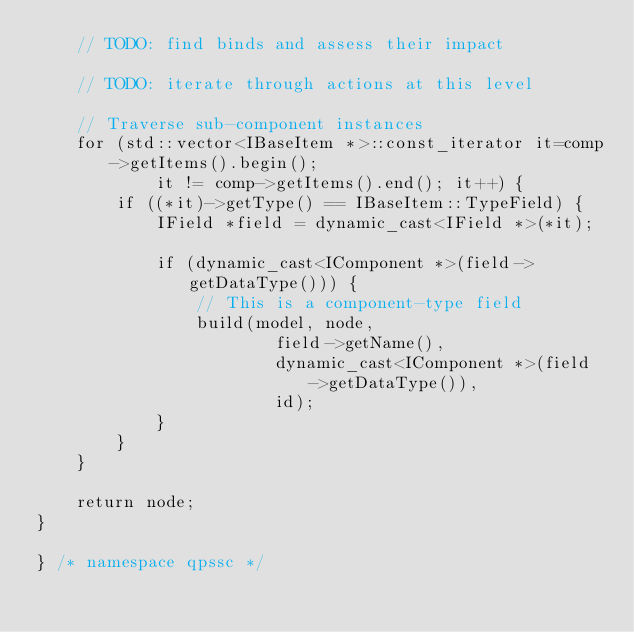Convert code to text. <code><loc_0><loc_0><loc_500><loc_500><_C++_>	// TODO: find binds and assess their impact

	// TODO: iterate through actions at this level

	// Traverse sub-component instances
	for (std::vector<IBaseItem *>::const_iterator it=comp->getItems().begin();
			it != comp->getItems().end(); it++) {
		if ((*it)->getType() == IBaseItem::TypeField) {
			IField *field = dynamic_cast<IField *>(*it);

			if (dynamic_cast<IComponent *>(field->getDataType())) {
				// This is a component-type field
				build(model, node,
						field->getName(),
						dynamic_cast<IComponent *>(field->getDataType()),
						id);
			}
		}
	}

	return node;
}

} /* namespace qpssc */
</code> 